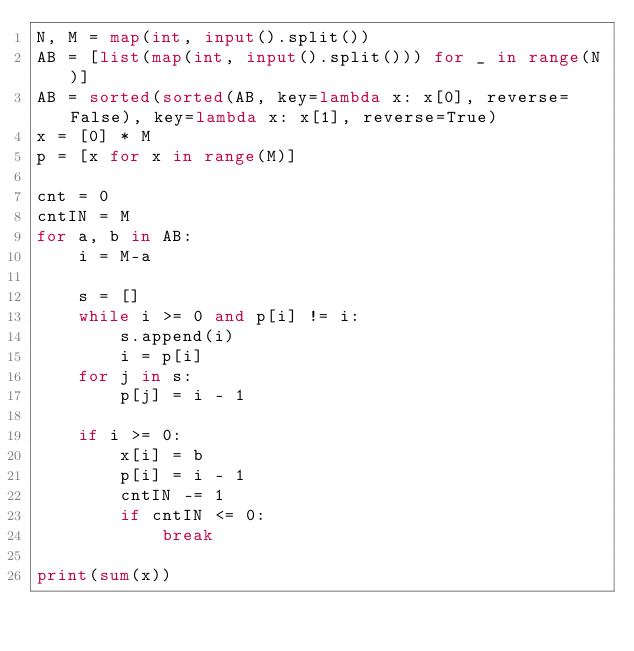<code> <loc_0><loc_0><loc_500><loc_500><_Python_>N, M = map(int, input().split())
AB = [list(map(int, input().split())) for _ in range(N)]
AB = sorted(sorted(AB, key=lambda x: x[0], reverse=False), key=lambda x: x[1], reverse=True)
x = [0] * M
p = [x for x in range(M)]

cnt = 0
cntIN = M
for a, b in AB:
    i = M-a

    s = []
    while i >= 0 and p[i] != i:
        s.append(i)
        i = p[i]
    for j in s:
        p[j] = i - 1

    if i >= 0:
        x[i] = b
        p[i] = i - 1
        cntIN -= 1            
        if cntIN <= 0:
            break

print(sum(x))
</code> 